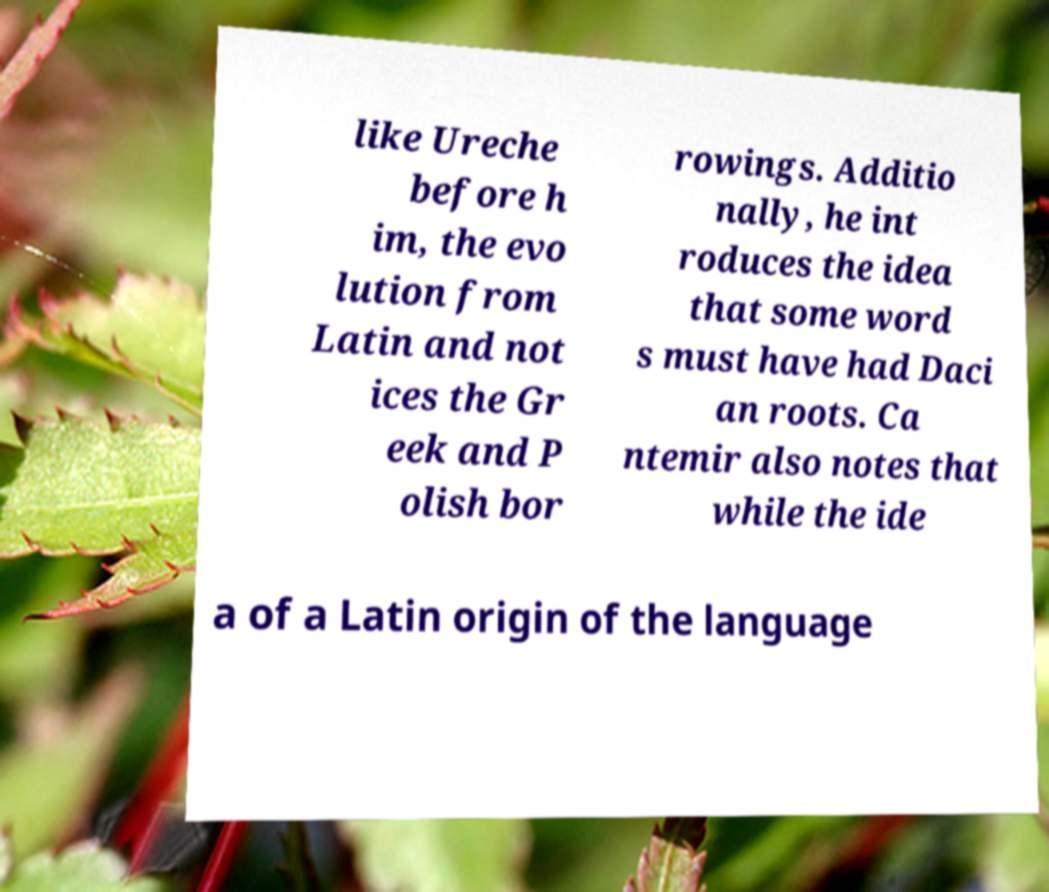For documentation purposes, I need the text within this image transcribed. Could you provide that? like Ureche before h im, the evo lution from Latin and not ices the Gr eek and P olish bor rowings. Additio nally, he int roduces the idea that some word s must have had Daci an roots. Ca ntemir also notes that while the ide a of a Latin origin of the language 